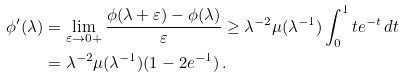<formula> <loc_0><loc_0><loc_500><loc_500>\phi ^ { \prime } ( \lambda ) & = \lim _ { \varepsilon \to 0 + } \frac { \phi ( \lambda + \varepsilon ) - \phi ( \lambda ) } { \varepsilon } \geq \lambda ^ { - 2 } \mu ( \lambda ^ { - 1 } ) \int _ { 0 } ^ { 1 } t e ^ { - t } \, d t \\ & = \lambda ^ { - 2 } \mu ( \lambda ^ { - 1 } ) ( 1 - 2 e ^ { - 1 } ) \, .</formula> 